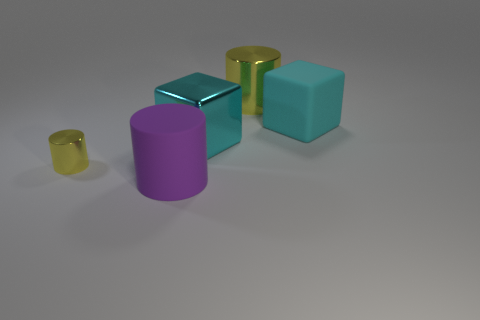What materials are the objects made of in this image? In the image, the objects seem to be composed of different materials. The object with a reflective surface is likely metallic, while the others with a matte finish resemble rubber. 